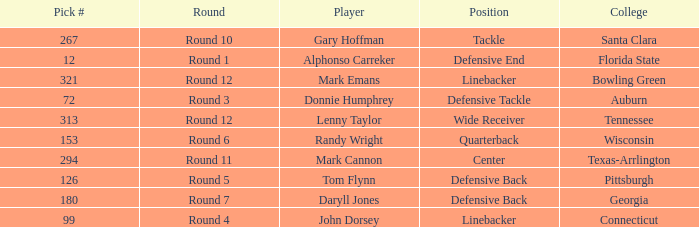What Player is a Wide Receiver? Lenny Taylor. 